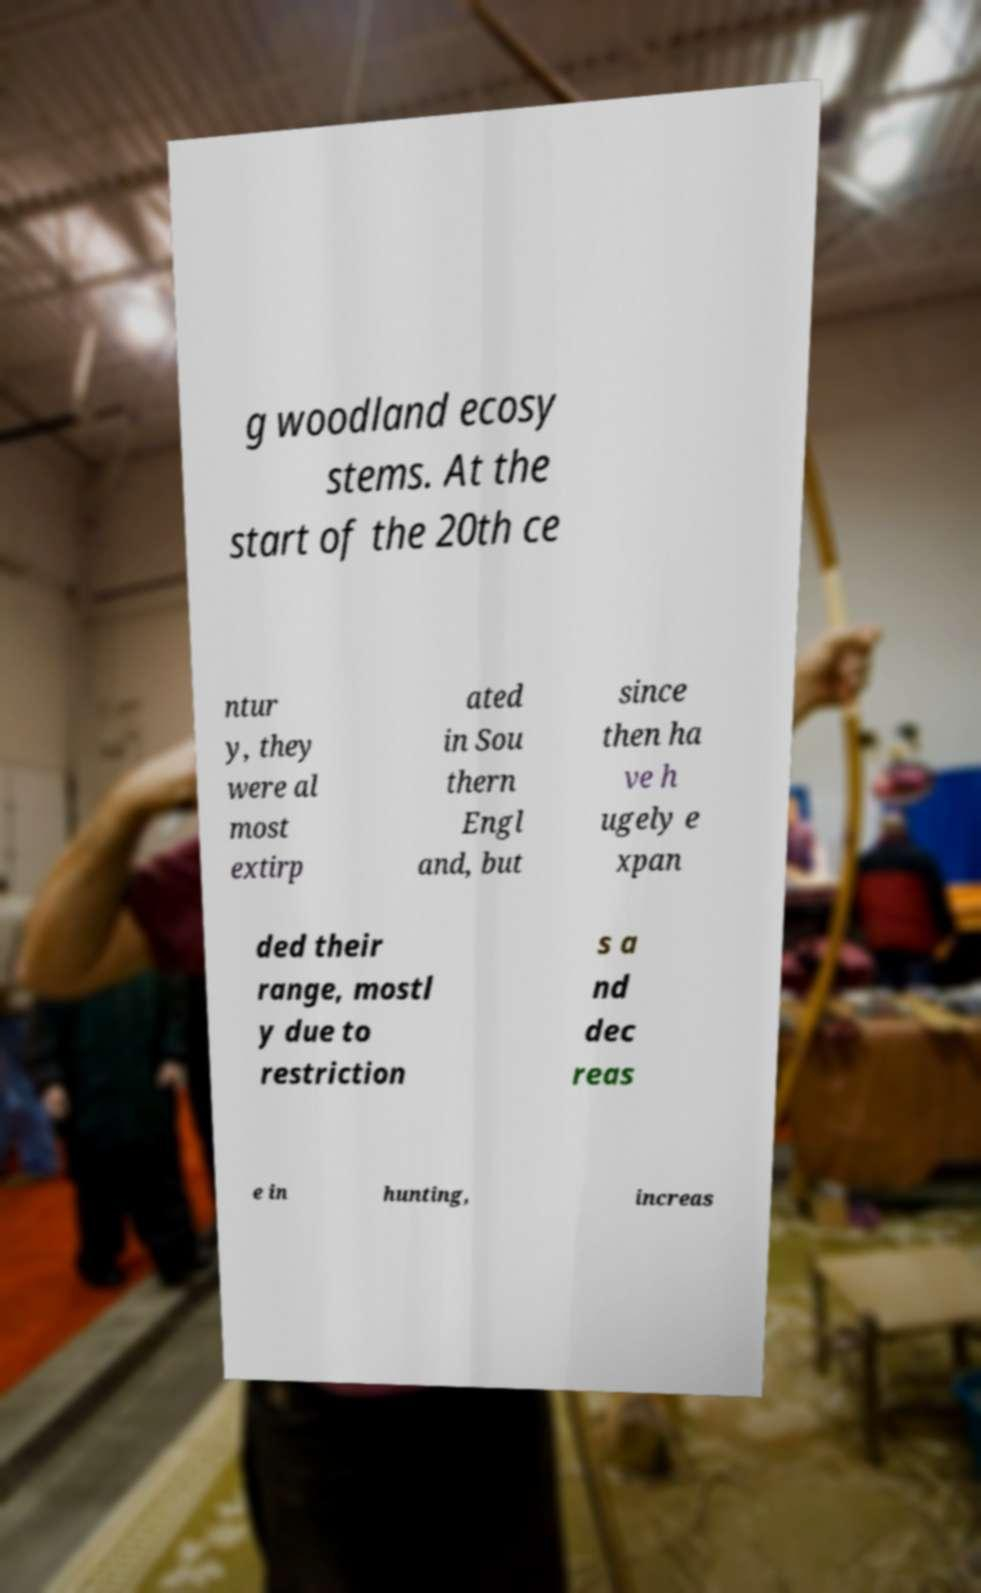Can you accurately transcribe the text from the provided image for me? g woodland ecosy stems. At the start of the 20th ce ntur y, they were al most extirp ated in Sou thern Engl and, but since then ha ve h ugely e xpan ded their range, mostl y due to restriction s a nd dec reas e in hunting, increas 